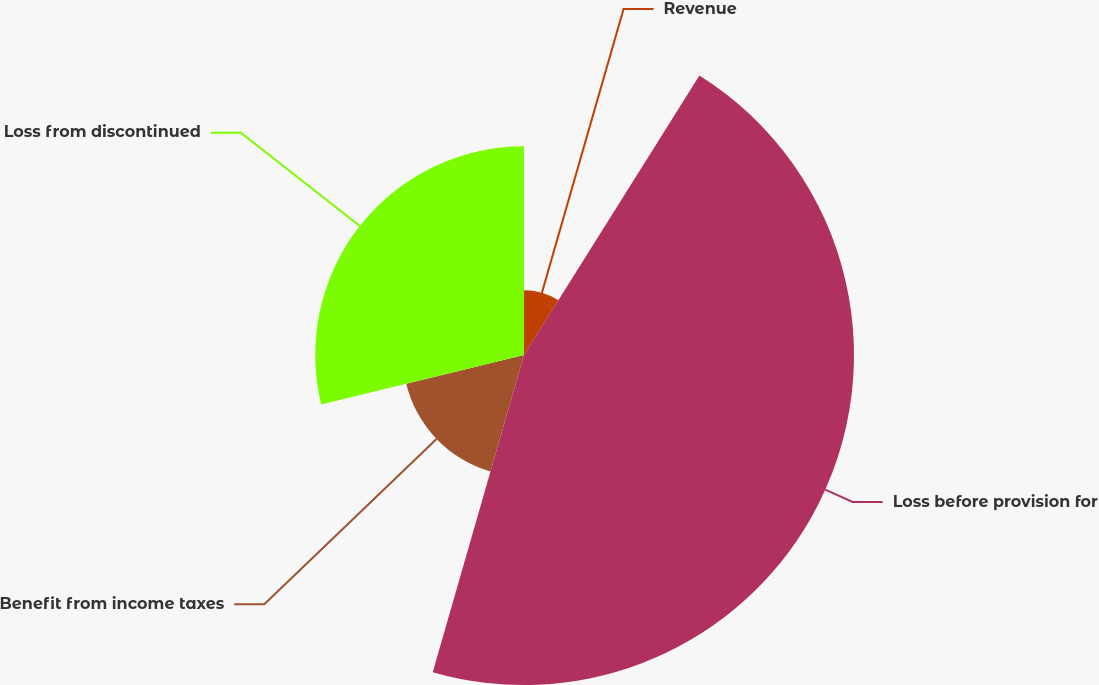Convert chart. <chart><loc_0><loc_0><loc_500><loc_500><pie_chart><fcel>Revenue<fcel>Loss before provision for<fcel>Benefit from income taxes<fcel>Loss from discontinued<nl><fcel>8.92%<fcel>45.54%<fcel>16.73%<fcel>28.81%<nl></chart> 